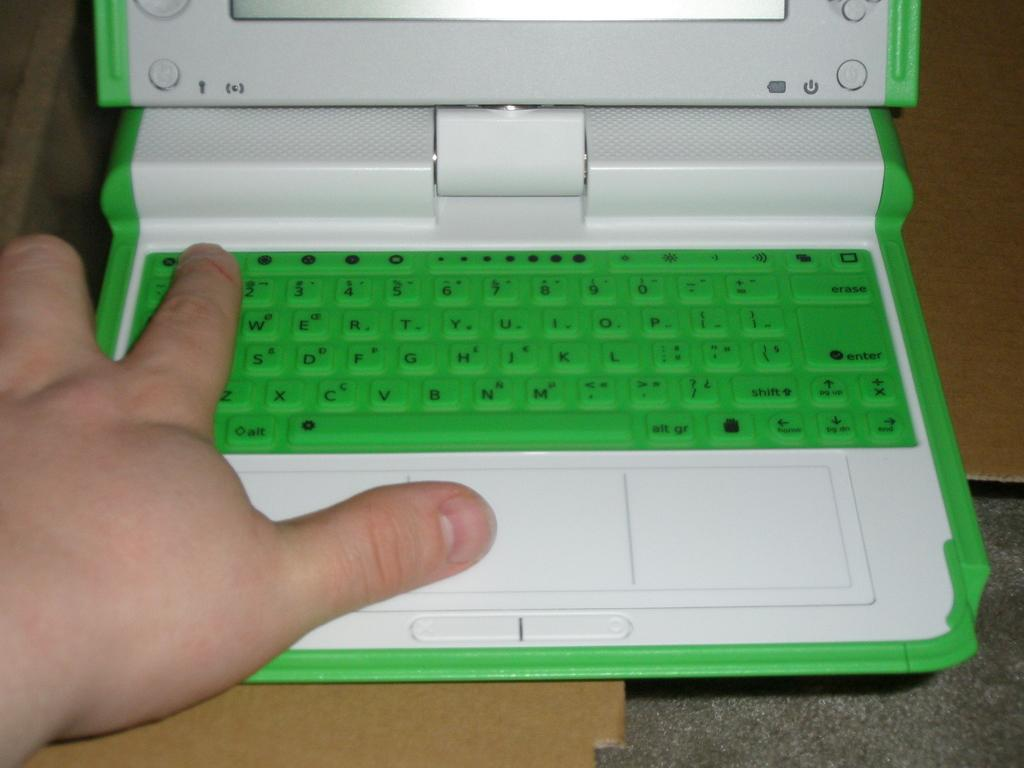<image>
Provide a brief description of the given image. The up and down buttons on the green keyboard are located below the enter button 